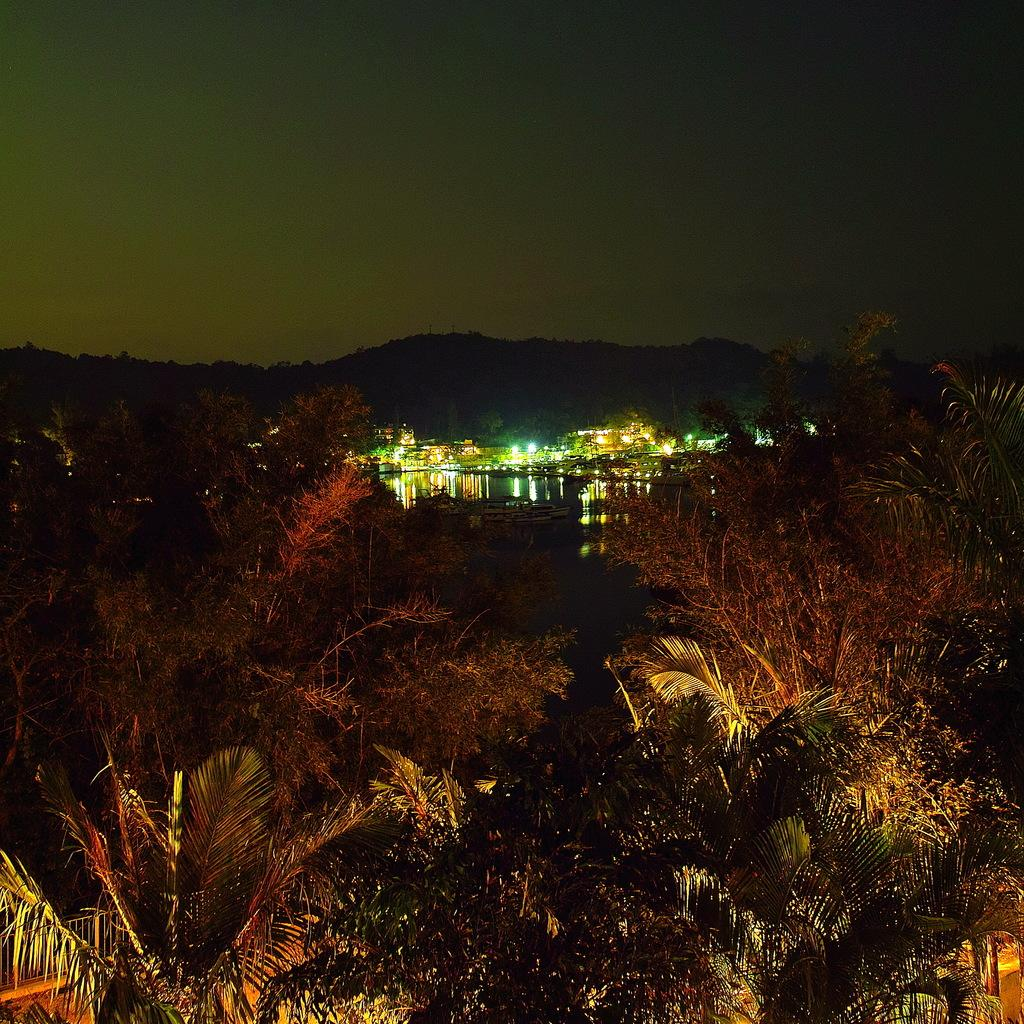What type of natural elements can be seen in the image? There are trees in the image. What type of man-made structures are present in the image? There are buildings in the image. What type of illumination is visible in the image? There are lights in the image. What type of geographical feature can be seen in the image? There is a mountain in the image. What part of the natural environment is visible in the image? The sky is visible in the image. What type of current can be seen flowing through the mountain in the image? There is no current visible in the image, and the mountain does not have any flowing water. What type of silver object is present in the image? There is no silver object present in the image. 